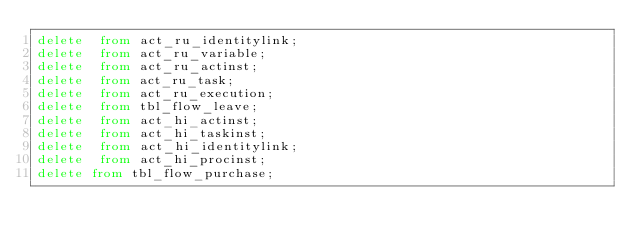Convert code to text. <code><loc_0><loc_0><loc_500><loc_500><_SQL_>delete  from act_ru_identitylink;
delete  from act_ru_variable;
delete  from act_ru_actinst;
delete  from act_ru_task;
delete  from act_ru_execution;
delete  from tbl_flow_leave;
delete  from act_hi_actinst;
delete  from act_hi_taskinst;
delete  from act_hi_identitylink;
delete  from act_hi_procinst;
delete from tbl_flow_purchase;

</code> 